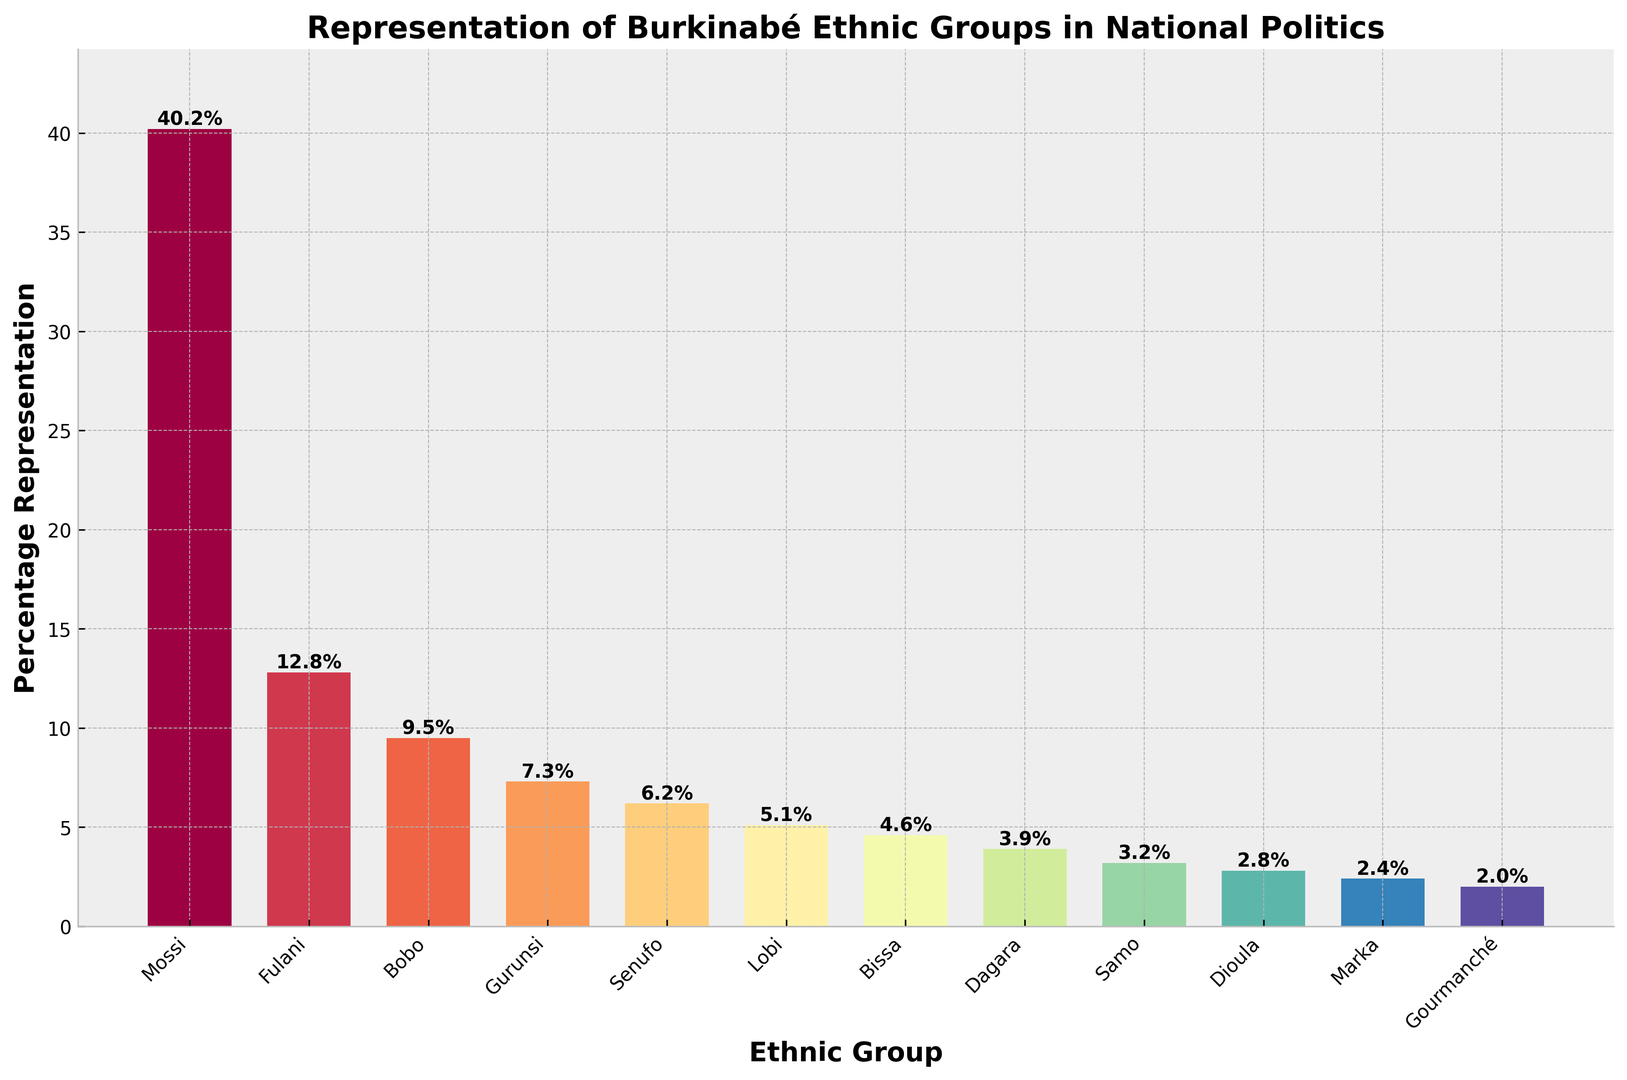Which ethnic group has the highest representation in national politics? By looking at the heights of the bars, the Mossi ethnic group has the tallest bar, indicating that they have the highest representation.
Answer: Mossi What is the combined percentage representation of the Gurunsi and Senufo ethnic groups? By adding the heights of the bars for Gurunsi (7.3%) and Senufo (6.2%), the combined percentage is 7.3% + 6.2% = 13.5%.
Answer: 13.5% Which two ethnic groups have the smallest difference in their percentage representation? By comparing the heights of all the bars, the smallest difference is between Dioula (2.8%) and Marka (2.4%), which is 2.8% - 2.4% = 0.4%.
Answer: Dioula and Marka What is the average percentage representation of the Bobo, Lobi, and Samo ethnic groups? Adding the percentages of Bobo (9.5%), Lobi (5.1%), and Samo (3.2%) gives 9.5% + 5.1% + 3.2% = 17.8%. Dividing by 3 gives an average of 17.8% / 3 ≈ 5.93%.
Answer: 5.93% Which group is represented by a dark color near the top and has a representation just under 10%? By visual inspection, the Bobo ethnic group is represented by a dark color near the top and has a percentage just under 10% (9.5%).
Answer: Bobo How much higher is the representation of the Mossi group compared to the Dioula group? Subtract the percentage of the Dioula group (2.8%) from the percentage of the Mossi group (40.2%) to get 40.2% - 2.8% = 37.4%.
Answer: 37.4% What percentage of the total representation is contributed by the Lobi, Bissa, and Dagara ethnic groups combined? Adding the percentages of Lobi (5.1%), Bissa (4.6%), and Dagara (3.9%) gives 5.1% + 4.6% + 3.9% = 13.6%.
Answer: 13.6% Which ethnic group has a representation closest to the median given the data? First, arrange the percentages in order: 2.0%, 2.4%, 2.8%, 3.2%, 3.9%, 4.6%, 5.1%, 6.2%, 7.3%, 9.5%, 12.8%, 40.2%. The median is the average of the 6th and 7th numbers: (4.6% + 5.1%) / 2 = 4.85%. The Bissa group, closest to 4.85%, has 4.6%.
Answer: Bissa Identify the ethnic group with the lightest colored bar in the chart. By visual inspection, the lightest colored bar corresponds to the Gourmanché ethnic group.
Answer: Gourmanché 